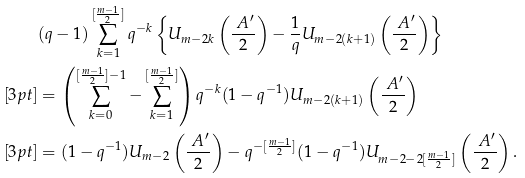Convert formula to latex. <formula><loc_0><loc_0><loc_500><loc_500>& ( q - 1 ) \sum ^ { [ \frac { m - 1 } { 2 } ] } _ { k = 1 } q ^ { - k } \left \{ U _ { m - 2 k } \left ( \frac { \ A ^ { \prime } } { 2 } \right ) - \frac { 1 } { q } U _ { m - 2 ( k + 1 ) } \left ( \frac { \ A ^ { \prime } } { 2 } \right ) \right \} \\ [ 3 p t ] & = \left ( \sum _ { k = 0 } ^ { [ \frac { m - 1 } { 2 } ] - 1 } - \sum _ { k = 1 } ^ { [ \frac { m - 1 } { 2 } ] } \right ) q ^ { - k } ( 1 - q ^ { - 1 } ) U _ { m - 2 ( k + 1 ) } \left ( \frac { \ A ^ { \prime } } { 2 } \right ) \\ [ 3 p t ] & = ( 1 - q ^ { - 1 } ) U _ { m - 2 } \left ( \frac { \ A ^ { \prime } } { 2 } \right ) - q ^ { - [ \frac { m - 1 } { 2 } ] } ( 1 - q ^ { - 1 } ) U _ { m - 2 - 2 [ \frac { m - 1 } { 2 } ] } \left ( \frac { \ A ^ { \prime } } { 2 } \right ) .</formula> 